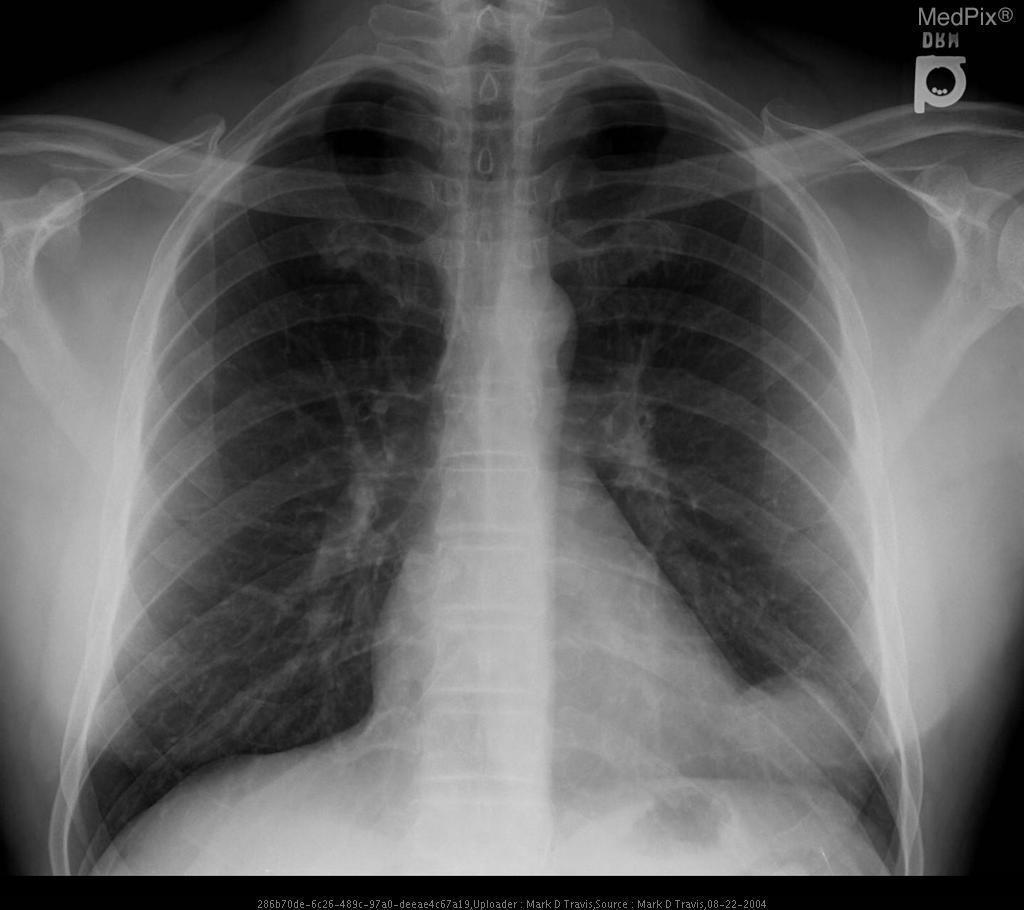Does this patient have an endotracheal tube placed?
Quick response, please. No. Does this cxr display pneumoperitoneum?
Short answer required. No. Which side of the image is the thoracic mass located on?
Quick response, please. Left side. 